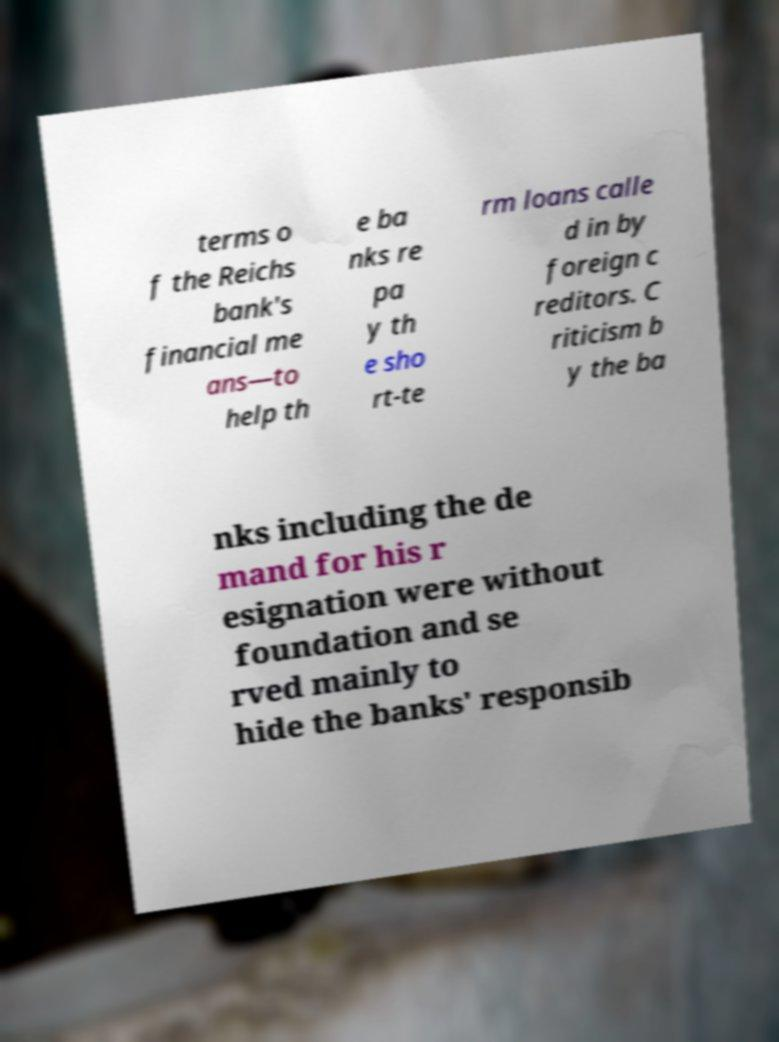Can you read and provide the text displayed in the image?This photo seems to have some interesting text. Can you extract and type it out for me? terms o f the Reichs bank's financial me ans—to help th e ba nks re pa y th e sho rt-te rm loans calle d in by foreign c reditors. C riticism b y the ba nks including the de mand for his r esignation were without foundation and se rved mainly to hide the banks' responsib 